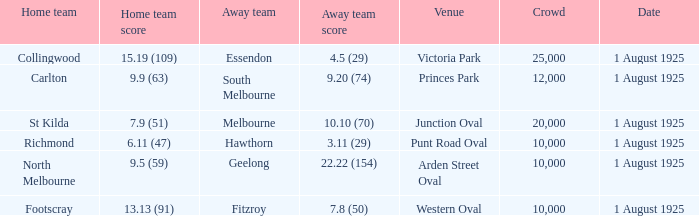What was the away team's score at the match played at The Western Oval? 7.8 (50). 